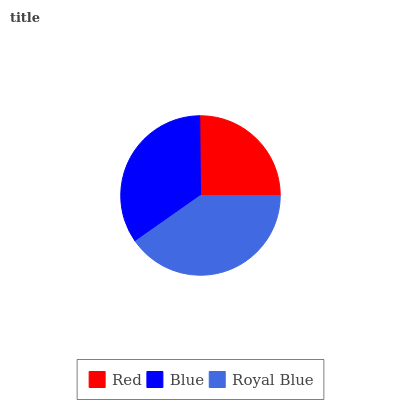Is Red the minimum?
Answer yes or no. Yes. Is Royal Blue the maximum?
Answer yes or no. Yes. Is Blue the minimum?
Answer yes or no. No. Is Blue the maximum?
Answer yes or no. No. Is Blue greater than Red?
Answer yes or no. Yes. Is Red less than Blue?
Answer yes or no. Yes. Is Red greater than Blue?
Answer yes or no. No. Is Blue less than Red?
Answer yes or no. No. Is Blue the high median?
Answer yes or no. Yes. Is Blue the low median?
Answer yes or no. Yes. Is Red the high median?
Answer yes or no. No. Is Royal Blue the low median?
Answer yes or no. No. 